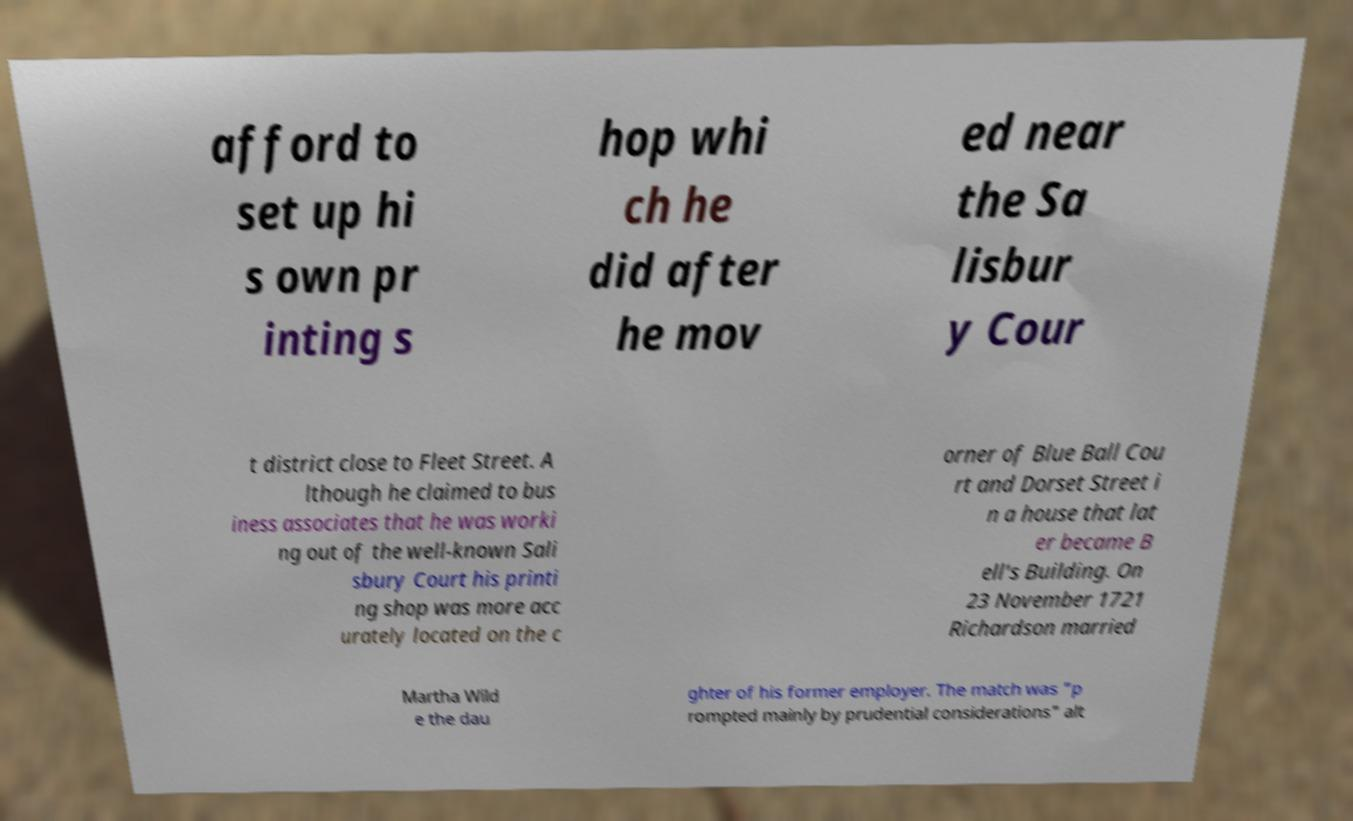Please identify and transcribe the text found in this image. afford to set up hi s own pr inting s hop whi ch he did after he mov ed near the Sa lisbur y Cour t district close to Fleet Street. A lthough he claimed to bus iness associates that he was worki ng out of the well-known Sali sbury Court his printi ng shop was more acc urately located on the c orner of Blue Ball Cou rt and Dorset Street i n a house that lat er became B ell's Building. On 23 November 1721 Richardson married Martha Wild e the dau ghter of his former employer. The match was "p rompted mainly by prudential considerations" alt 